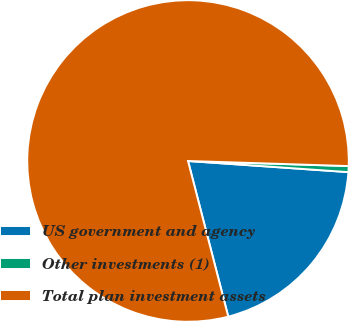<chart> <loc_0><loc_0><loc_500><loc_500><pie_chart><fcel>US government and agency<fcel>Other investments (1)<fcel>Total plan investment assets<nl><fcel>19.87%<fcel>0.6%<fcel>79.53%<nl></chart> 